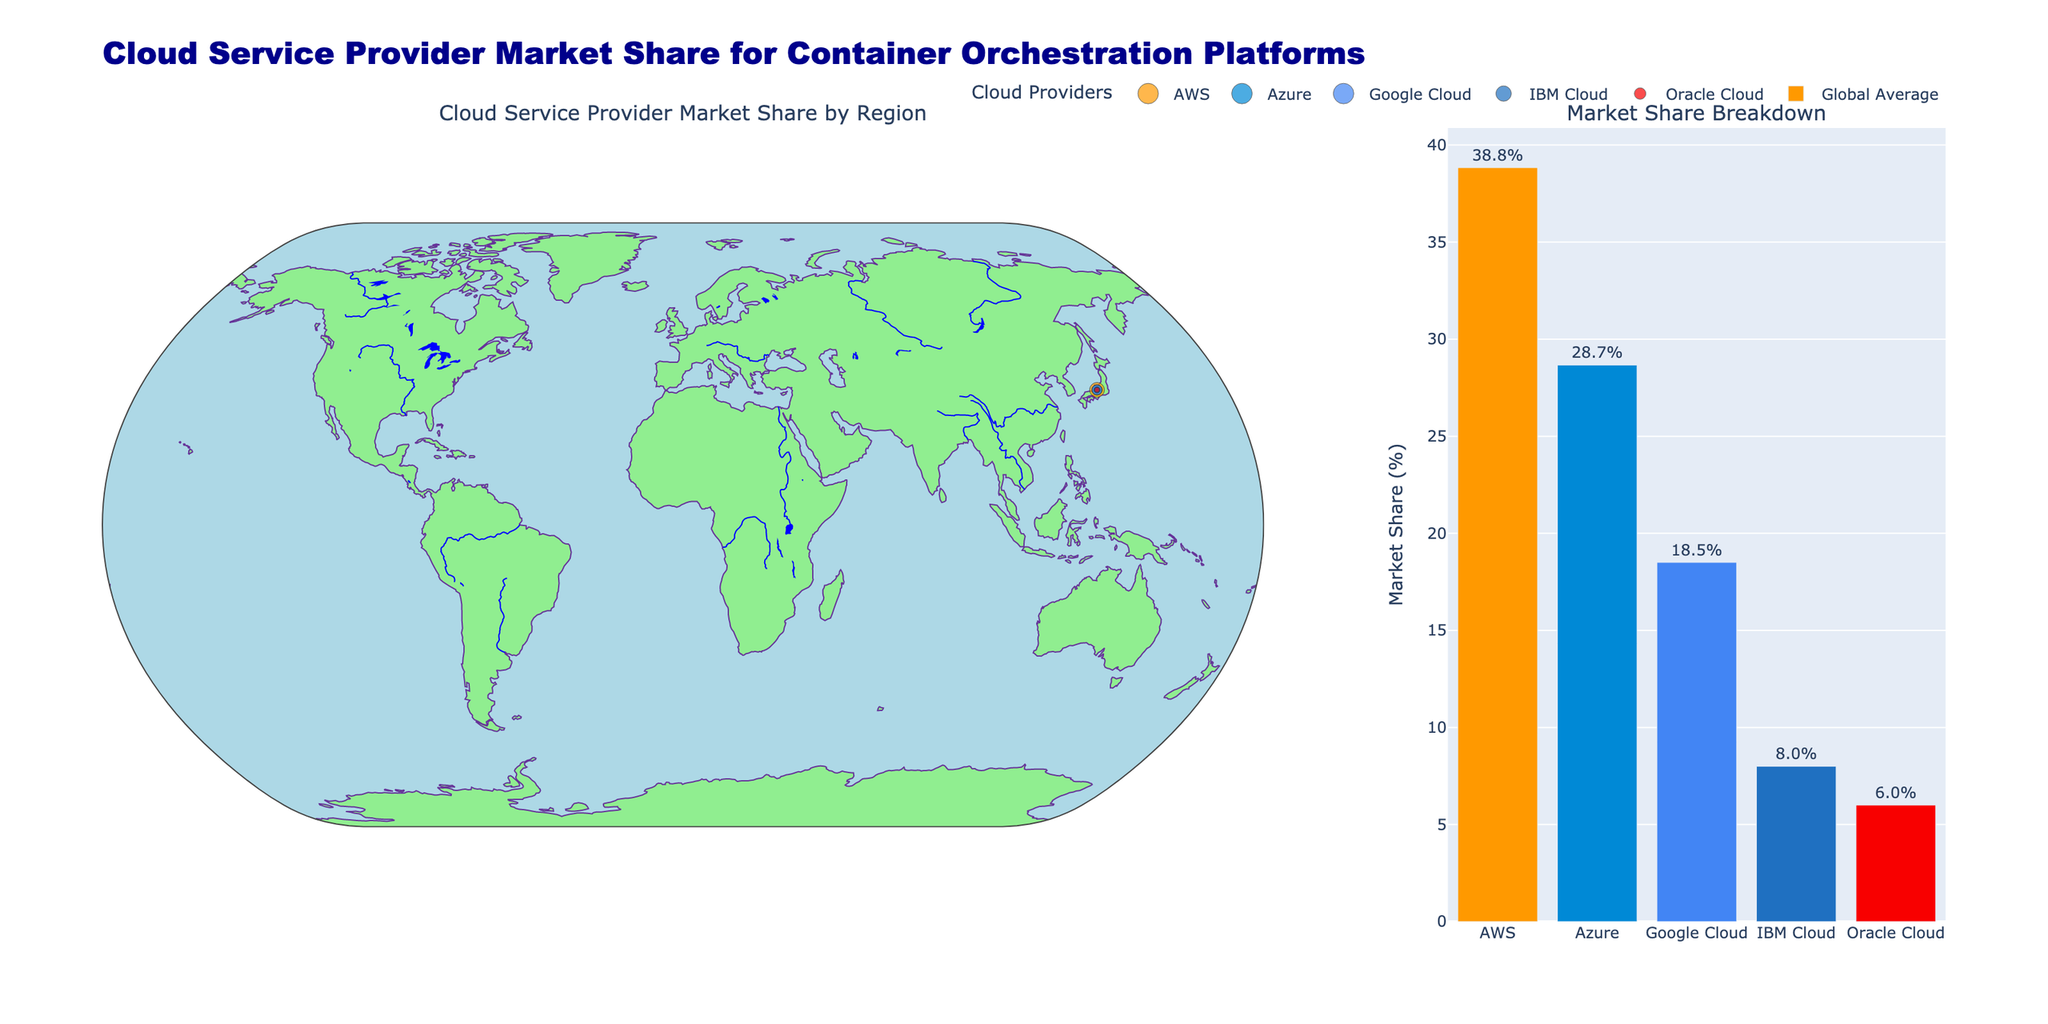What is the title of the plot? The title is located at the top of the figure and provides an overview of what the plot represents.
Answer: Cloud Service Provider Market Share for Container Orchestration Platforms Which cloud provider has the highest market share in North America? In the geographic map, we see the sizes of the markers representing each provider. The largest marker in North America corresponds to AWS, which shows the highest percentage.
Answer: AWS How does Azure's market share compare between North America and Europe? By looking at the size of the markers for Azure in North America and Europe, we can see that Azure has a 28% market share in North America and a 32% market share in Europe.
Answer: Azure has a higher market share in Europe than in North America What is the average market share of AWS across all regions? Refer to the bar chart on the right and look for the AWS bar. The average percentage value is provided as text outside the bar.
Answer: 38.8% Which region has the lowest market share for Google Cloud? On the geographic map, check the marker sizes corresponding to Google Cloud for each region. The smallest marker size in the Middle East and Africa signifies the lowest market share at 15%.
Answer: Middle East and Africa What is the combined market share of IBM Cloud and Oracle Cloud in Latin America? In Latin America, IBM Cloud has a 10% share, and Oracle Cloud has a 5% share. Adding them together: 10% + 5% = 15%.
Answer: 15% In which region does Oracle Cloud have the highest market share? Compare the marker sizes for Oracle Cloud across all regions. The largest marker is in the Middle East and Africa, indicating the highest market share at 8%.
Answer: Middle East and Africa What is the difference between the market shares of AWS and Google Cloud in the Asia Pacific region? In the Asia Pacific region, AWS has a 40% share, and Google Cloud has a 22% share. Subtracting the two: 40% - 22% = 18%.
Answer: 18% Which cloud provider has the smallest global average market share? In the bar chart, compare the heights of the bars and look at the value labels. Oracle Cloud has the smallest average market share.
Answer: Oracle Cloud Does any provider have a market share greater than 50% in any region? Look for markers larger than 50% on the map for each provider. The largest share marker is for AWS in Japan, at 45%, which is less than 50%.
Answer: No 